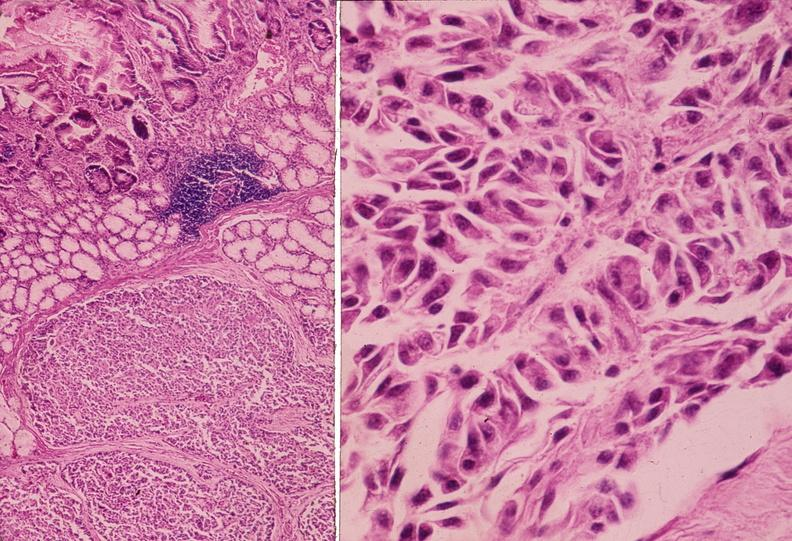where is this?
Answer the question using a single word or phrase. Pancreas 